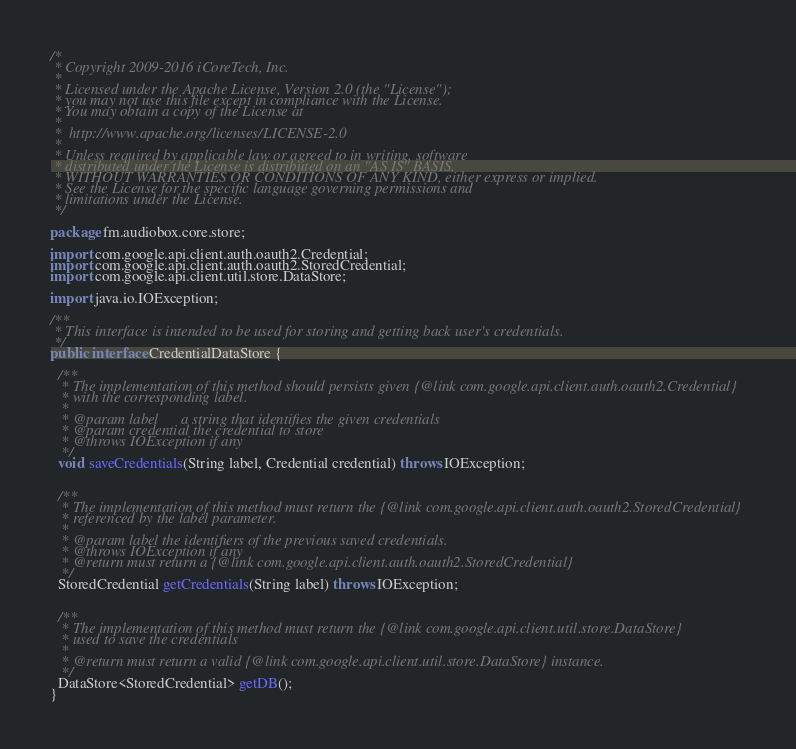<code> <loc_0><loc_0><loc_500><loc_500><_Java_>/*
 * Copyright 2009-2016 iCoreTech, Inc.
 *
 * Licensed under the Apache License, Version 2.0 (the "License");
 * you may not use this file except in compliance with the License.
 * You may obtain a copy of the License at
 *
 *  http://www.apache.org/licenses/LICENSE-2.0
 *
 * Unless required by applicable law or agreed to in writing, software
 * distributed under the License is distributed on an "AS IS" BASIS,
 * WITHOUT WARRANTIES OR CONDITIONS OF ANY KIND, either express or implied.
 * See the License for the specific language governing permissions and
 * limitations under the License.
 */

package fm.audiobox.core.store;

import com.google.api.client.auth.oauth2.Credential;
import com.google.api.client.auth.oauth2.StoredCredential;
import com.google.api.client.util.store.DataStore;

import java.io.IOException;

/**
 * This interface is intended to be used for storing and getting back user's credentials.
 */
public interface CredentialDataStore {

  /**
   * The implementation of this method should persists given {@link com.google.api.client.auth.oauth2.Credential}
   * with the corresponding label.
   *
   * @param label      a string that identifies the given credentials
   * @param credential the credential to store
   * @throws IOException if any
   */
  void saveCredentials(String label, Credential credential) throws IOException;


  /**
   * The implementation of this method must return the {@link com.google.api.client.auth.oauth2.StoredCredential}
   * referenced by the label parameter.
   *
   * @param label the identifiers of the previous saved credentials.
   * @throws IOException if any
   * @return must return a {@link com.google.api.client.auth.oauth2.StoredCredential}
   */
  StoredCredential getCredentials(String label) throws IOException;


  /**
   * The implementation of this method must return the {@link com.google.api.client.util.store.DataStore}
   * used to save the credentials
   *
   * @return must return a valid {@link com.google.api.client.util.store.DataStore} instance.
   */
  DataStore<StoredCredential> getDB();
}
</code> 